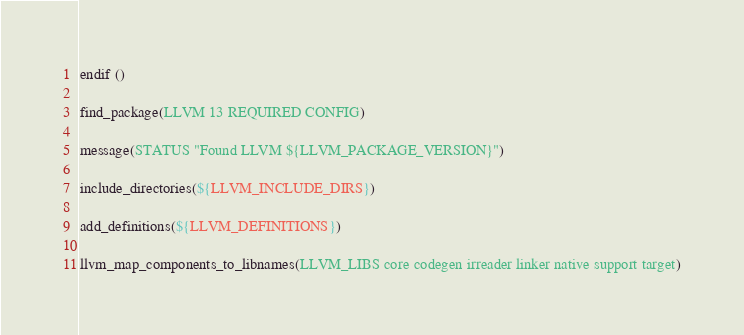Convert code to text. <code><loc_0><loc_0><loc_500><loc_500><_CMake_>endif ()

find_package(LLVM 13 REQUIRED CONFIG)

message(STATUS "Found LLVM ${LLVM_PACKAGE_VERSION}")

include_directories(${LLVM_INCLUDE_DIRS})

add_definitions(${LLVM_DEFINITIONS})

llvm_map_components_to_libnames(LLVM_LIBS core codegen irreader linker native support target)
</code> 